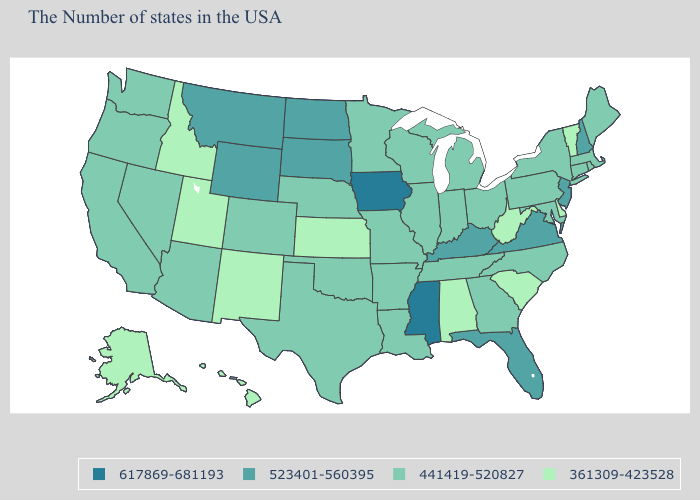Is the legend a continuous bar?
Answer briefly. No. What is the lowest value in the South?
Short answer required. 361309-423528. Among the states that border Maryland , which have the highest value?
Short answer required. Virginia. Name the states that have a value in the range 361309-423528?
Keep it brief. Vermont, Delaware, South Carolina, West Virginia, Alabama, Kansas, New Mexico, Utah, Idaho, Alaska, Hawaii. What is the highest value in states that border Oklahoma?
Give a very brief answer. 441419-520827. What is the lowest value in the MidWest?
Be succinct. 361309-423528. What is the value of Wisconsin?
Answer briefly. 441419-520827. Does the map have missing data?
Write a very short answer. No. Does Mississippi have the highest value in the USA?
Be succinct. Yes. Does Mississippi have the highest value in the USA?
Be succinct. Yes. What is the lowest value in the South?
Short answer required. 361309-423528. Does Vermont have the same value as Delaware?
Give a very brief answer. Yes. Does Mississippi have the highest value in the South?
Keep it brief. Yes. What is the value of South Carolina?
Write a very short answer. 361309-423528. 